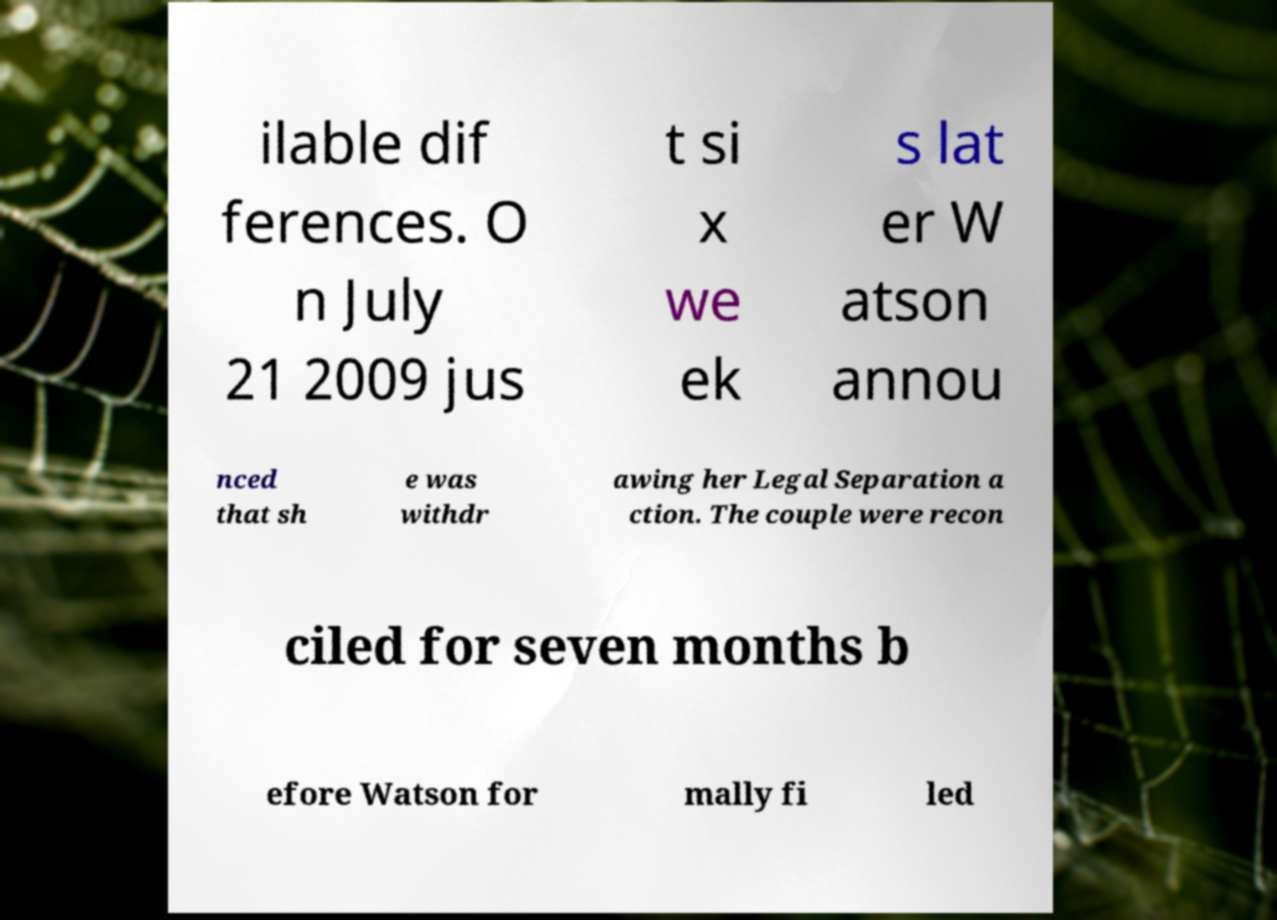There's text embedded in this image that I need extracted. Can you transcribe it verbatim? ilable dif ferences. O n July 21 2009 jus t si x we ek s lat er W atson annou nced that sh e was withdr awing her Legal Separation a ction. The couple were recon ciled for seven months b efore Watson for mally fi led 